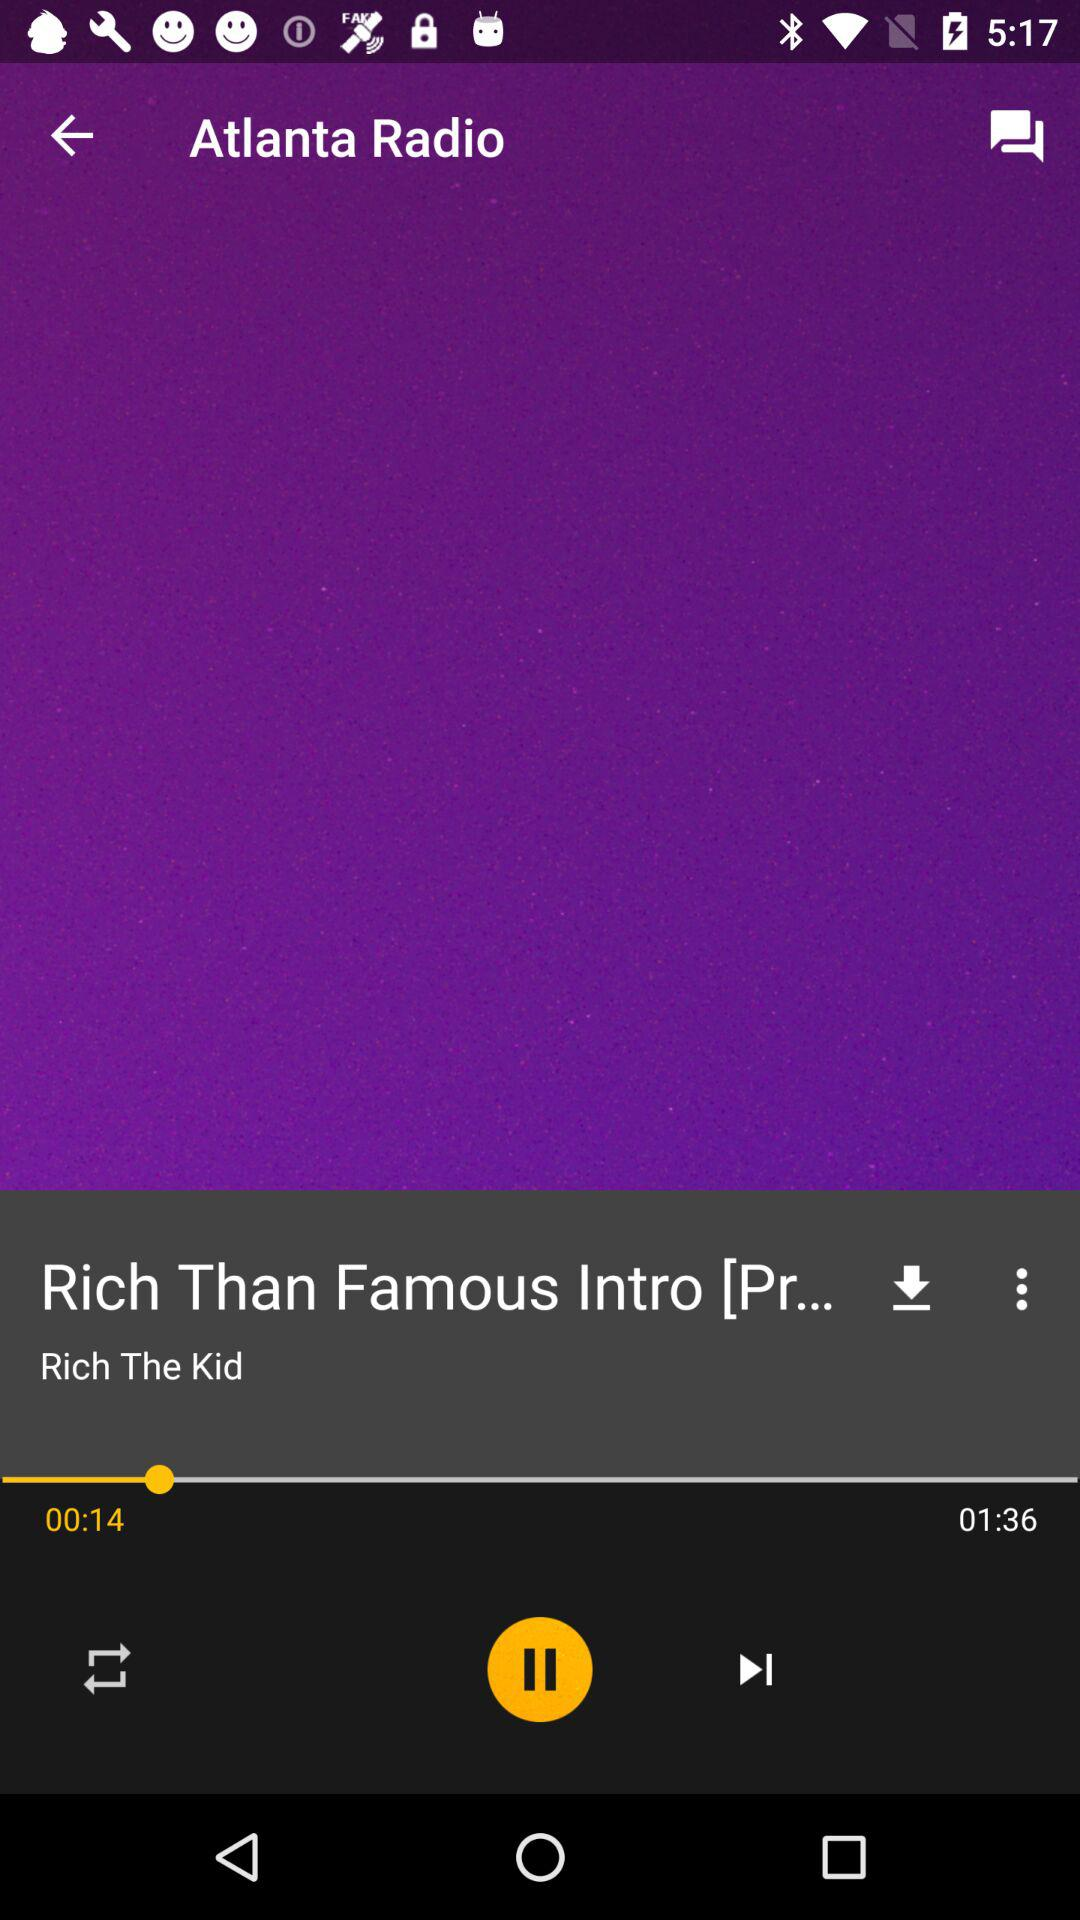Who is the singer of the song "Rich Than Famous"? The singer of the song "Rich Than Famous" is Rich The Kid. 